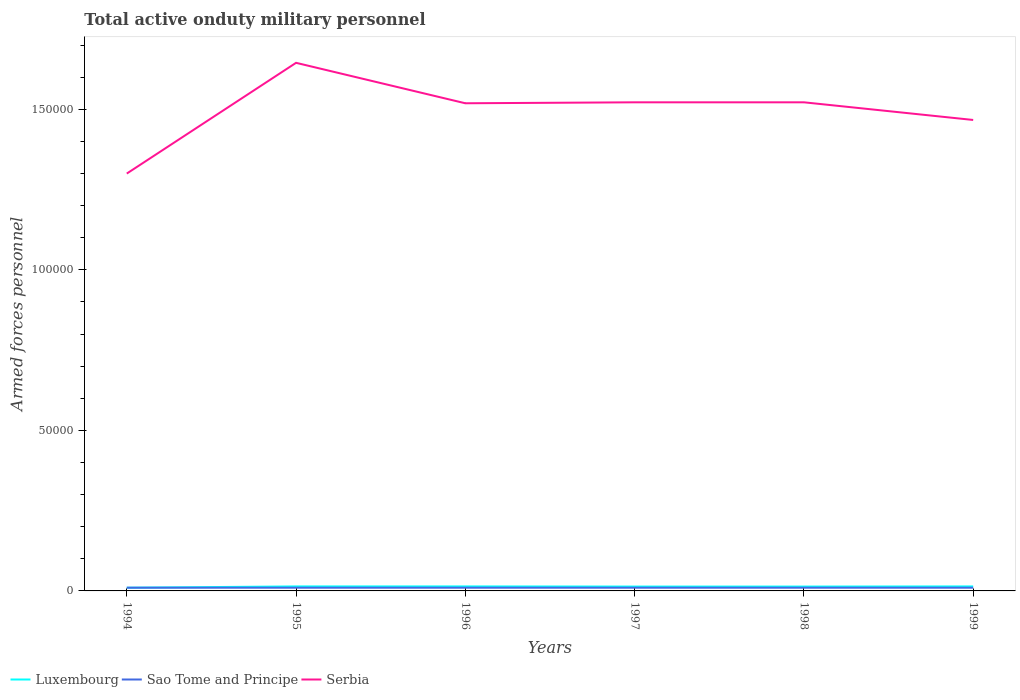Does the line corresponding to Sao Tome and Principe intersect with the line corresponding to Luxembourg?
Provide a short and direct response. Yes. Is the number of lines equal to the number of legend labels?
Give a very brief answer. Yes. Across all years, what is the maximum number of armed forces personnel in Sao Tome and Principe?
Offer a terse response. 1000. What is the total number of armed forces personnel in Luxembourg in the graph?
Keep it short and to the point. 40. What is the difference between the highest and the lowest number of armed forces personnel in Luxembourg?
Make the answer very short. 5. Is the number of armed forces personnel in Luxembourg strictly greater than the number of armed forces personnel in Sao Tome and Principe over the years?
Your answer should be very brief. No. How many years are there in the graph?
Provide a short and direct response. 6. What is the difference between two consecutive major ticks on the Y-axis?
Offer a very short reply. 5.00e+04. Does the graph contain grids?
Ensure brevity in your answer.  No. What is the title of the graph?
Provide a short and direct response. Total active onduty military personnel. Does "Latin America(all income levels)" appear as one of the legend labels in the graph?
Make the answer very short. No. What is the label or title of the X-axis?
Your response must be concise. Years. What is the label or title of the Y-axis?
Ensure brevity in your answer.  Armed forces personnel. What is the Armed forces personnel in Luxembourg in 1995?
Provide a succinct answer. 1400. What is the Armed forces personnel of Sao Tome and Principe in 1995?
Your answer should be compact. 1000. What is the Armed forces personnel in Serbia in 1995?
Provide a short and direct response. 1.64e+05. What is the Armed forces personnel in Luxembourg in 1996?
Give a very brief answer. 1400. What is the Armed forces personnel in Serbia in 1996?
Your response must be concise. 1.52e+05. What is the Armed forces personnel of Luxembourg in 1997?
Ensure brevity in your answer.  1360. What is the Armed forces personnel in Serbia in 1997?
Provide a succinct answer. 1.52e+05. What is the Armed forces personnel in Luxembourg in 1998?
Make the answer very short. 1360. What is the Armed forces personnel in Sao Tome and Principe in 1998?
Your answer should be very brief. 1000. What is the Armed forces personnel of Serbia in 1998?
Offer a terse response. 1.52e+05. What is the Armed forces personnel in Luxembourg in 1999?
Keep it short and to the point. 1400. What is the Armed forces personnel of Sao Tome and Principe in 1999?
Ensure brevity in your answer.  1000. What is the Armed forces personnel of Serbia in 1999?
Keep it short and to the point. 1.47e+05. Across all years, what is the maximum Armed forces personnel in Luxembourg?
Give a very brief answer. 1400. Across all years, what is the maximum Armed forces personnel in Serbia?
Ensure brevity in your answer.  1.64e+05. Across all years, what is the minimum Armed forces personnel in Luxembourg?
Ensure brevity in your answer.  1000. Across all years, what is the minimum Armed forces personnel of Serbia?
Provide a succinct answer. 1.30e+05. What is the total Armed forces personnel in Luxembourg in the graph?
Provide a succinct answer. 7920. What is the total Armed forces personnel in Sao Tome and Principe in the graph?
Offer a very short reply. 6000. What is the total Armed forces personnel in Serbia in the graph?
Provide a short and direct response. 8.98e+05. What is the difference between the Armed forces personnel of Luxembourg in 1994 and that in 1995?
Keep it short and to the point. -400. What is the difference between the Armed forces personnel in Serbia in 1994 and that in 1995?
Ensure brevity in your answer.  -3.45e+04. What is the difference between the Armed forces personnel in Luxembourg in 1994 and that in 1996?
Provide a short and direct response. -400. What is the difference between the Armed forces personnel in Sao Tome and Principe in 1994 and that in 1996?
Ensure brevity in your answer.  0. What is the difference between the Armed forces personnel in Serbia in 1994 and that in 1996?
Provide a succinct answer. -2.19e+04. What is the difference between the Armed forces personnel of Luxembourg in 1994 and that in 1997?
Your answer should be very brief. -360. What is the difference between the Armed forces personnel in Serbia in 1994 and that in 1997?
Provide a short and direct response. -2.22e+04. What is the difference between the Armed forces personnel of Luxembourg in 1994 and that in 1998?
Offer a very short reply. -360. What is the difference between the Armed forces personnel in Serbia in 1994 and that in 1998?
Provide a succinct answer. -2.22e+04. What is the difference between the Armed forces personnel of Luxembourg in 1994 and that in 1999?
Your answer should be compact. -400. What is the difference between the Armed forces personnel in Serbia in 1994 and that in 1999?
Provide a succinct answer. -1.67e+04. What is the difference between the Armed forces personnel in Luxembourg in 1995 and that in 1996?
Provide a succinct answer. 0. What is the difference between the Armed forces personnel in Serbia in 1995 and that in 1996?
Ensure brevity in your answer.  1.26e+04. What is the difference between the Armed forces personnel in Luxembourg in 1995 and that in 1997?
Keep it short and to the point. 40. What is the difference between the Armed forces personnel of Sao Tome and Principe in 1995 and that in 1997?
Your answer should be very brief. 0. What is the difference between the Armed forces personnel in Serbia in 1995 and that in 1997?
Offer a terse response. 1.23e+04. What is the difference between the Armed forces personnel of Luxembourg in 1995 and that in 1998?
Provide a short and direct response. 40. What is the difference between the Armed forces personnel in Sao Tome and Principe in 1995 and that in 1998?
Offer a terse response. 0. What is the difference between the Armed forces personnel in Serbia in 1995 and that in 1998?
Ensure brevity in your answer.  1.23e+04. What is the difference between the Armed forces personnel in Sao Tome and Principe in 1995 and that in 1999?
Your answer should be very brief. 0. What is the difference between the Armed forces personnel in Serbia in 1995 and that in 1999?
Ensure brevity in your answer.  1.78e+04. What is the difference between the Armed forces personnel of Luxembourg in 1996 and that in 1997?
Your answer should be very brief. 40. What is the difference between the Armed forces personnel in Sao Tome and Principe in 1996 and that in 1997?
Your answer should be very brief. 0. What is the difference between the Armed forces personnel in Serbia in 1996 and that in 1997?
Keep it short and to the point. -300. What is the difference between the Armed forces personnel of Luxembourg in 1996 and that in 1998?
Your response must be concise. 40. What is the difference between the Armed forces personnel of Sao Tome and Principe in 1996 and that in 1998?
Your answer should be very brief. 0. What is the difference between the Armed forces personnel of Serbia in 1996 and that in 1998?
Provide a succinct answer. -300. What is the difference between the Armed forces personnel in Luxembourg in 1996 and that in 1999?
Offer a very short reply. 0. What is the difference between the Armed forces personnel of Sao Tome and Principe in 1996 and that in 1999?
Ensure brevity in your answer.  0. What is the difference between the Armed forces personnel in Serbia in 1996 and that in 1999?
Offer a terse response. 5200. What is the difference between the Armed forces personnel of Sao Tome and Principe in 1997 and that in 1998?
Ensure brevity in your answer.  0. What is the difference between the Armed forces personnel in Serbia in 1997 and that in 1998?
Offer a very short reply. 0. What is the difference between the Armed forces personnel of Luxembourg in 1997 and that in 1999?
Provide a succinct answer. -40. What is the difference between the Armed forces personnel of Serbia in 1997 and that in 1999?
Offer a terse response. 5500. What is the difference between the Armed forces personnel of Luxembourg in 1998 and that in 1999?
Keep it short and to the point. -40. What is the difference between the Armed forces personnel in Serbia in 1998 and that in 1999?
Keep it short and to the point. 5500. What is the difference between the Armed forces personnel in Luxembourg in 1994 and the Armed forces personnel in Serbia in 1995?
Provide a succinct answer. -1.64e+05. What is the difference between the Armed forces personnel of Sao Tome and Principe in 1994 and the Armed forces personnel of Serbia in 1995?
Ensure brevity in your answer.  -1.64e+05. What is the difference between the Armed forces personnel of Luxembourg in 1994 and the Armed forces personnel of Sao Tome and Principe in 1996?
Give a very brief answer. 0. What is the difference between the Armed forces personnel of Luxembourg in 1994 and the Armed forces personnel of Serbia in 1996?
Your response must be concise. -1.51e+05. What is the difference between the Armed forces personnel in Sao Tome and Principe in 1994 and the Armed forces personnel in Serbia in 1996?
Your answer should be compact. -1.51e+05. What is the difference between the Armed forces personnel of Luxembourg in 1994 and the Armed forces personnel of Serbia in 1997?
Give a very brief answer. -1.51e+05. What is the difference between the Armed forces personnel of Sao Tome and Principe in 1994 and the Armed forces personnel of Serbia in 1997?
Your answer should be very brief. -1.51e+05. What is the difference between the Armed forces personnel of Luxembourg in 1994 and the Armed forces personnel of Serbia in 1998?
Make the answer very short. -1.51e+05. What is the difference between the Armed forces personnel of Sao Tome and Principe in 1994 and the Armed forces personnel of Serbia in 1998?
Provide a succinct answer. -1.51e+05. What is the difference between the Armed forces personnel in Luxembourg in 1994 and the Armed forces personnel in Serbia in 1999?
Provide a short and direct response. -1.46e+05. What is the difference between the Armed forces personnel of Sao Tome and Principe in 1994 and the Armed forces personnel of Serbia in 1999?
Your answer should be very brief. -1.46e+05. What is the difference between the Armed forces personnel in Luxembourg in 1995 and the Armed forces personnel in Sao Tome and Principe in 1996?
Offer a very short reply. 400. What is the difference between the Armed forces personnel in Luxembourg in 1995 and the Armed forces personnel in Serbia in 1996?
Provide a short and direct response. -1.50e+05. What is the difference between the Armed forces personnel of Sao Tome and Principe in 1995 and the Armed forces personnel of Serbia in 1996?
Provide a short and direct response. -1.51e+05. What is the difference between the Armed forces personnel in Luxembourg in 1995 and the Armed forces personnel in Sao Tome and Principe in 1997?
Give a very brief answer. 400. What is the difference between the Armed forces personnel of Luxembourg in 1995 and the Armed forces personnel of Serbia in 1997?
Give a very brief answer. -1.51e+05. What is the difference between the Armed forces personnel in Sao Tome and Principe in 1995 and the Armed forces personnel in Serbia in 1997?
Your response must be concise. -1.51e+05. What is the difference between the Armed forces personnel of Luxembourg in 1995 and the Armed forces personnel of Serbia in 1998?
Offer a very short reply. -1.51e+05. What is the difference between the Armed forces personnel of Sao Tome and Principe in 1995 and the Armed forces personnel of Serbia in 1998?
Keep it short and to the point. -1.51e+05. What is the difference between the Armed forces personnel of Luxembourg in 1995 and the Armed forces personnel of Sao Tome and Principe in 1999?
Provide a succinct answer. 400. What is the difference between the Armed forces personnel in Luxembourg in 1995 and the Armed forces personnel in Serbia in 1999?
Offer a terse response. -1.45e+05. What is the difference between the Armed forces personnel of Sao Tome and Principe in 1995 and the Armed forces personnel of Serbia in 1999?
Make the answer very short. -1.46e+05. What is the difference between the Armed forces personnel of Luxembourg in 1996 and the Armed forces personnel of Sao Tome and Principe in 1997?
Your response must be concise. 400. What is the difference between the Armed forces personnel in Luxembourg in 1996 and the Armed forces personnel in Serbia in 1997?
Offer a terse response. -1.51e+05. What is the difference between the Armed forces personnel in Sao Tome and Principe in 1996 and the Armed forces personnel in Serbia in 1997?
Provide a short and direct response. -1.51e+05. What is the difference between the Armed forces personnel in Luxembourg in 1996 and the Armed forces personnel in Serbia in 1998?
Your answer should be compact. -1.51e+05. What is the difference between the Armed forces personnel in Sao Tome and Principe in 1996 and the Armed forces personnel in Serbia in 1998?
Give a very brief answer. -1.51e+05. What is the difference between the Armed forces personnel of Luxembourg in 1996 and the Armed forces personnel of Sao Tome and Principe in 1999?
Offer a very short reply. 400. What is the difference between the Armed forces personnel of Luxembourg in 1996 and the Armed forces personnel of Serbia in 1999?
Offer a terse response. -1.45e+05. What is the difference between the Armed forces personnel of Sao Tome and Principe in 1996 and the Armed forces personnel of Serbia in 1999?
Give a very brief answer. -1.46e+05. What is the difference between the Armed forces personnel in Luxembourg in 1997 and the Armed forces personnel in Sao Tome and Principe in 1998?
Keep it short and to the point. 360. What is the difference between the Armed forces personnel of Luxembourg in 1997 and the Armed forces personnel of Serbia in 1998?
Offer a terse response. -1.51e+05. What is the difference between the Armed forces personnel of Sao Tome and Principe in 1997 and the Armed forces personnel of Serbia in 1998?
Your answer should be very brief. -1.51e+05. What is the difference between the Armed forces personnel in Luxembourg in 1997 and the Armed forces personnel in Sao Tome and Principe in 1999?
Your answer should be very brief. 360. What is the difference between the Armed forces personnel in Luxembourg in 1997 and the Armed forces personnel in Serbia in 1999?
Keep it short and to the point. -1.45e+05. What is the difference between the Armed forces personnel in Sao Tome and Principe in 1997 and the Armed forces personnel in Serbia in 1999?
Give a very brief answer. -1.46e+05. What is the difference between the Armed forces personnel of Luxembourg in 1998 and the Armed forces personnel of Sao Tome and Principe in 1999?
Ensure brevity in your answer.  360. What is the difference between the Armed forces personnel in Luxembourg in 1998 and the Armed forces personnel in Serbia in 1999?
Keep it short and to the point. -1.45e+05. What is the difference between the Armed forces personnel in Sao Tome and Principe in 1998 and the Armed forces personnel in Serbia in 1999?
Ensure brevity in your answer.  -1.46e+05. What is the average Armed forces personnel in Luxembourg per year?
Provide a succinct answer. 1320. What is the average Armed forces personnel of Sao Tome and Principe per year?
Your response must be concise. 1000. What is the average Armed forces personnel in Serbia per year?
Provide a short and direct response. 1.50e+05. In the year 1994, what is the difference between the Armed forces personnel of Luxembourg and Armed forces personnel of Sao Tome and Principe?
Make the answer very short. 0. In the year 1994, what is the difference between the Armed forces personnel in Luxembourg and Armed forces personnel in Serbia?
Offer a very short reply. -1.29e+05. In the year 1994, what is the difference between the Armed forces personnel in Sao Tome and Principe and Armed forces personnel in Serbia?
Offer a terse response. -1.29e+05. In the year 1995, what is the difference between the Armed forces personnel in Luxembourg and Armed forces personnel in Sao Tome and Principe?
Provide a succinct answer. 400. In the year 1995, what is the difference between the Armed forces personnel of Luxembourg and Armed forces personnel of Serbia?
Your answer should be compact. -1.63e+05. In the year 1995, what is the difference between the Armed forces personnel in Sao Tome and Principe and Armed forces personnel in Serbia?
Provide a short and direct response. -1.64e+05. In the year 1996, what is the difference between the Armed forces personnel of Luxembourg and Armed forces personnel of Serbia?
Offer a very short reply. -1.50e+05. In the year 1996, what is the difference between the Armed forces personnel in Sao Tome and Principe and Armed forces personnel in Serbia?
Ensure brevity in your answer.  -1.51e+05. In the year 1997, what is the difference between the Armed forces personnel of Luxembourg and Armed forces personnel of Sao Tome and Principe?
Provide a succinct answer. 360. In the year 1997, what is the difference between the Armed forces personnel in Luxembourg and Armed forces personnel in Serbia?
Your answer should be very brief. -1.51e+05. In the year 1997, what is the difference between the Armed forces personnel of Sao Tome and Principe and Armed forces personnel of Serbia?
Your response must be concise. -1.51e+05. In the year 1998, what is the difference between the Armed forces personnel of Luxembourg and Armed forces personnel of Sao Tome and Principe?
Offer a very short reply. 360. In the year 1998, what is the difference between the Armed forces personnel of Luxembourg and Armed forces personnel of Serbia?
Provide a succinct answer. -1.51e+05. In the year 1998, what is the difference between the Armed forces personnel of Sao Tome and Principe and Armed forces personnel of Serbia?
Your answer should be compact. -1.51e+05. In the year 1999, what is the difference between the Armed forces personnel in Luxembourg and Armed forces personnel in Serbia?
Offer a very short reply. -1.45e+05. In the year 1999, what is the difference between the Armed forces personnel of Sao Tome and Principe and Armed forces personnel of Serbia?
Your response must be concise. -1.46e+05. What is the ratio of the Armed forces personnel in Luxembourg in 1994 to that in 1995?
Your response must be concise. 0.71. What is the ratio of the Armed forces personnel of Serbia in 1994 to that in 1995?
Offer a very short reply. 0.79. What is the ratio of the Armed forces personnel in Serbia in 1994 to that in 1996?
Provide a short and direct response. 0.86. What is the ratio of the Armed forces personnel in Luxembourg in 1994 to that in 1997?
Give a very brief answer. 0.74. What is the ratio of the Armed forces personnel of Sao Tome and Principe in 1994 to that in 1997?
Offer a very short reply. 1. What is the ratio of the Armed forces personnel in Serbia in 1994 to that in 1997?
Your response must be concise. 0.85. What is the ratio of the Armed forces personnel of Luxembourg in 1994 to that in 1998?
Your response must be concise. 0.74. What is the ratio of the Armed forces personnel in Sao Tome and Principe in 1994 to that in 1998?
Provide a succinct answer. 1. What is the ratio of the Armed forces personnel of Serbia in 1994 to that in 1998?
Offer a very short reply. 0.85. What is the ratio of the Armed forces personnel in Luxembourg in 1994 to that in 1999?
Offer a very short reply. 0.71. What is the ratio of the Armed forces personnel of Sao Tome and Principe in 1994 to that in 1999?
Keep it short and to the point. 1. What is the ratio of the Armed forces personnel in Serbia in 1994 to that in 1999?
Your response must be concise. 0.89. What is the ratio of the Armed forces personnel of Luxembourg in 1995 to that in 1996?
Offer a terse response. 1. What is the ratio of the Armed forces personnel of Serbia in 1995 to that in 1996?
Provide a succinct answer. 1.08. What is the ratio of the Armed forces personnel in Luxembourg in 1995 to that in 1997?
Provide a succinct answer. 1.03. What is the ratio of the Armed forces personnel of Sao Tome and Principe in 1995 to that in 1997?
Your answer should be compact. 1. What is the ratio of the Armed forces personnel in Serbia in 1995 to that in 1997?
Offer a terse response. 1.08. What is the ratio of the Armed forces personnel of Luxembourg in 1995 to that in 1998?
Offer a terse response. 1.03. What is the ratio of the Armed forces personnel of Sao Tome and Principe in 1995 to that in 1998?
Keep it short and to the point. 1. What is the ratio of the Armed forces personnel of Serbia in 1995 to that in 1998?
Your answer should be very brief. 1.08. What is the ratio of the Armed forces personnel in Serbia in 1995 to that in 1999?
Your response must be concise. 1.12. What is the ratio of the Armed forces personnel in Luxembourg in 1996 to that in 1997?
Give a very brief answer. 1.03. What is the ratio of the Armed forces personnel in Luxembourg in 1996 to that in 1998?
Offer a very short reply. 1.03. What is the ratio of the Armed forces personnel in Sao Tome and Principe in 1996 to that in 1998?
Offer a terse response. 1. What is the ratio of the Armed forces personnel in Serbia in 1996 to that in 1998?
Offer a terse response. 1. What is the ratio of the Armed forces personnel of Serbia in 1996 to that in 1999?
Provide a short and direct response. 1.04. What is the ratio of the Armed forces personnel in Luxembourg in 1997 to that in 1998?
Your answer should be very brief. 1. What is the ratio of the Armed forces personnel of Sao Tome and Principe in 1997 to that in 1998?
Offer a very short reply. 1. What is the ratio of the Armed forces personnel in Serbia in 1997 to that in 1998?
Your answer should be very brief. 1. What is the ratio of the Armed forces personnel of Luxembourg in 1997 to that in 1999?
Offer a terse response. 0.97. What is the ratio of the Armed forces personnel in Sao Tome and Principe in 1997 to that in 1999?
Give a very brief answer. 1. What is the ratio of the Armed forces personnel of Serbia in 1997 to that in 1999?
Your response must be concise. 1.04. What is the ratio of the Armed forces personnel in Luxembourg in 1998 to that in 1999?
Keep it short and to the point. 0.97. What is the ratio of the Armed forces personnel of Sao Tome and Principe in 1998 to that in 1999?
Provide a succinct answer. 1. What is the ratio of the Armed forces personnel in Serbia in 1998 to that in 1999?
Make the answer very short. 1.04. What is the difference between the highest and the second highest Armed forces personnel of Serbia?
Offer a terse response. 1.23e+04. What is the difference between the highest and the lowest Armed forces personnel of Luxembourg?
Your answer should be very brief. 400. What is the difference between the highest and the lowest Armed forces personnel in Serbia?
Keep it short and to the point. 3.45e+04. 